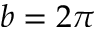<formula> <loc_0><loc_0><loc_500><loc_500>b = 2 \pi</formula> 